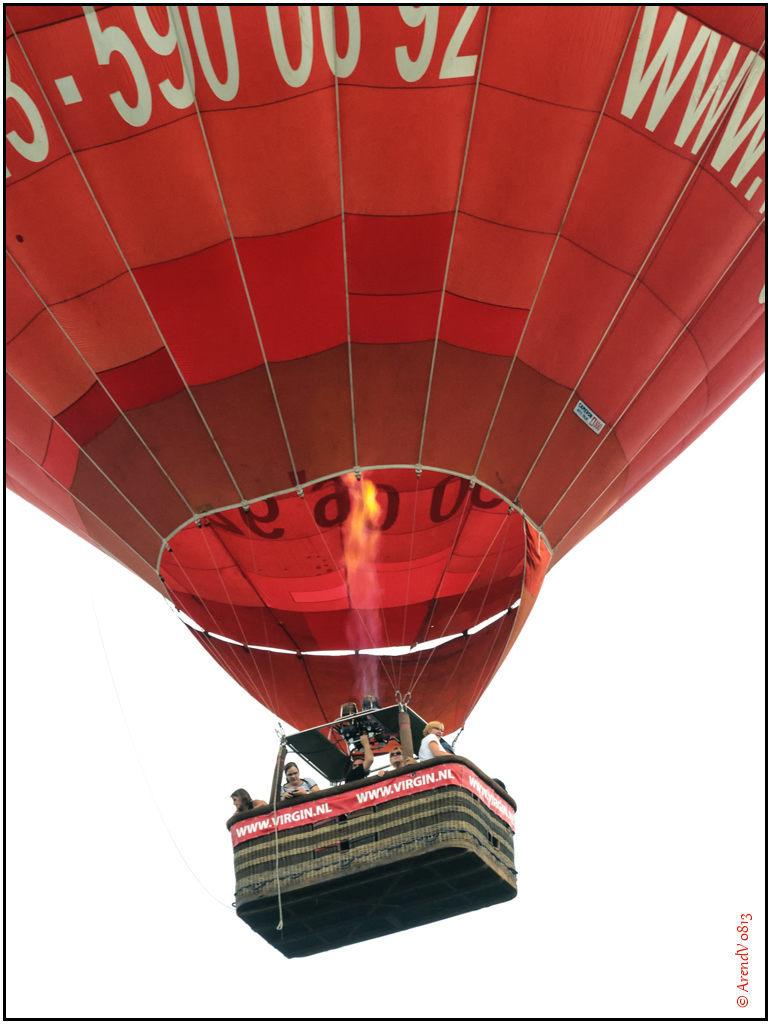What is the main object in the image? There is a parachute in the image. Are there any people associated with the parachute? Yes, there are people on the parachute. What color is the background of the image? The background of the image is white. How many beds can be seen in the image? There are no beds present in the image. 